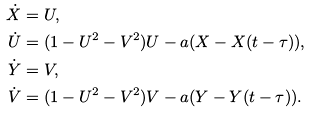<formula> <loc_0><loc_0><loc_500><loc_500>\dot { X } & = U , \\ \dot { U } & = ( 1 - U ^ { 2 } - V ^ { 2 } ) U - a ( X - X ( t - \tau ) ) , \\ \dot { Y } & = V , \\ \dot { V } & = ( 1 - U ^ { 2 } - V ^ { 2 } ) V - a ( Y - Y ( t - \tau ) ) .</formula> 